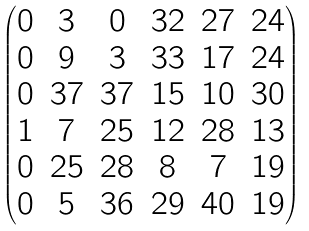Convert formula to latex. <formula><loc_0><loc_0><loc_500><loc_500>\begin{pmatrix} 0 & 3 & 0 & 3 2 & 2 7 & 2 4 \\ 0 & 9 & 3 & 3 3 & 1 7 & 2 4 \\ 0 & 3 7 & 3 7 & 1 5 & 1 0 & 3 0 \\ 1 & 7 & 2 5 & 1 2 & 2 8 & 1 3 \\ 0 & 2 5 & 2 8 & 8 & 7 & 1 9 \\ 0 & 5 & 3 6 & 2 9 & 4 0 & 1 9 \end{pmatrix}</formula> 